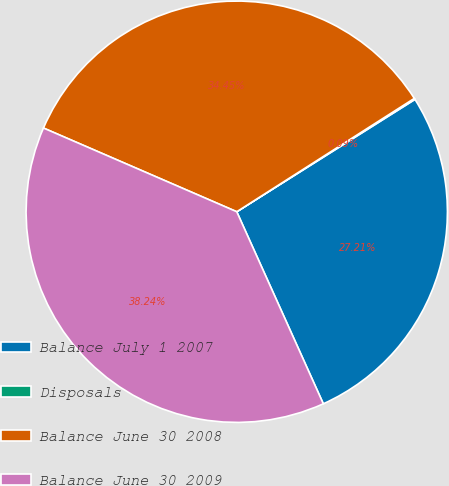<chart> <loc_0><loc_0><loc_500><loc_500><pie_chart><fcel>Balance July 1 2007<fcel>Disposals<fcel>Balance June 30 2008<fcel>Balance June 30 2009<nl><fcel>27.21%<fcel>0.09%<fcel>34.45%<fcel>38.24%<nl></chart> 